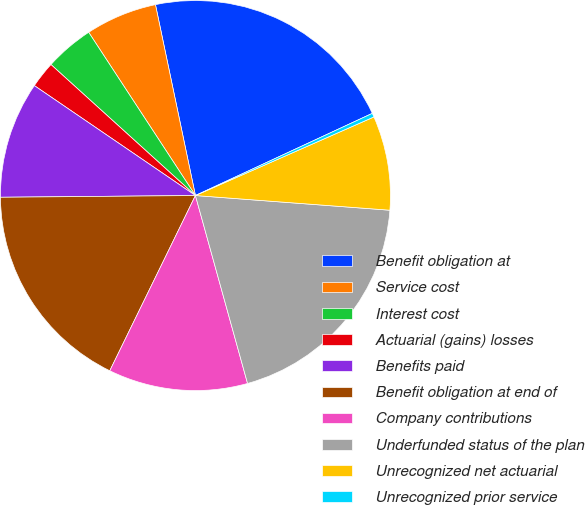<chart> <loc_0><loc_0><loc_500><loc_500><pie_chart><fcel>Benefit obligation at<fcel>Service cost<fcel>Interest cost<fcel>Actuarial (gains) losses<fcel>Benefits paid<fcel>Benefit obligation at end of<fcel>Company contributions<fcel>Underfunded status of the plan<fcel>Unrecognized net actuarial<fcel>Unrecognized prior service<nl><fcel>21.36%<fcel>5.93%<fcel>4.06%<fcel>2.19%<fcel>9.67%<fcel>17.62%<fcel>11.54%<fcel>19.49%<fcel>7.8%<fcel>0.32%<nl></chart> 